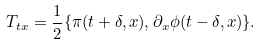Convert formula to latex. <formula><loc_0><loc_0><loc_500><loc_500>T _ { t x } = \frac { 1 } { 2 } \{ \pi ( t + \delta , x ) , \partial _ { x } \phi ( t - \delta , x ) \} .</formula> 